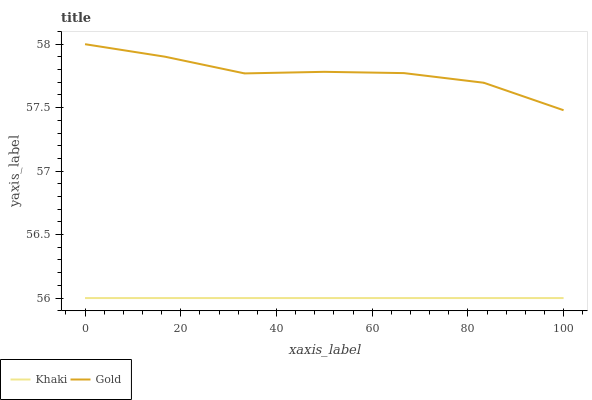Does Khaki have the minimum area under the curve?
Answer yes or no. Yes. Does Gold have the maximum area under the curve?
Answer yes or no. Yes. Does Gold have the minimum area under the curve?
Answer yes or no. No. Is Khaki the smoothest?
Answer yes or no. Yes. Is Gold the roughest?
Answer yes or no. Yes. Is Gold the smoothest?
Answer yes or no. No. Does Khaki have the lowest value?
Answer yes or no. Yes. Does Gold have the lowest value?
Answer yes or no. No. Does Gold have the highest value?
Answer yes or no. Yes. Is Khaki less than Gold?
Answer yes or no. Yes. Is Gold greater than Khaki?
Answer yes or no. Yes. Does Khaki intersect Gold?
Answer yes or no. No. 